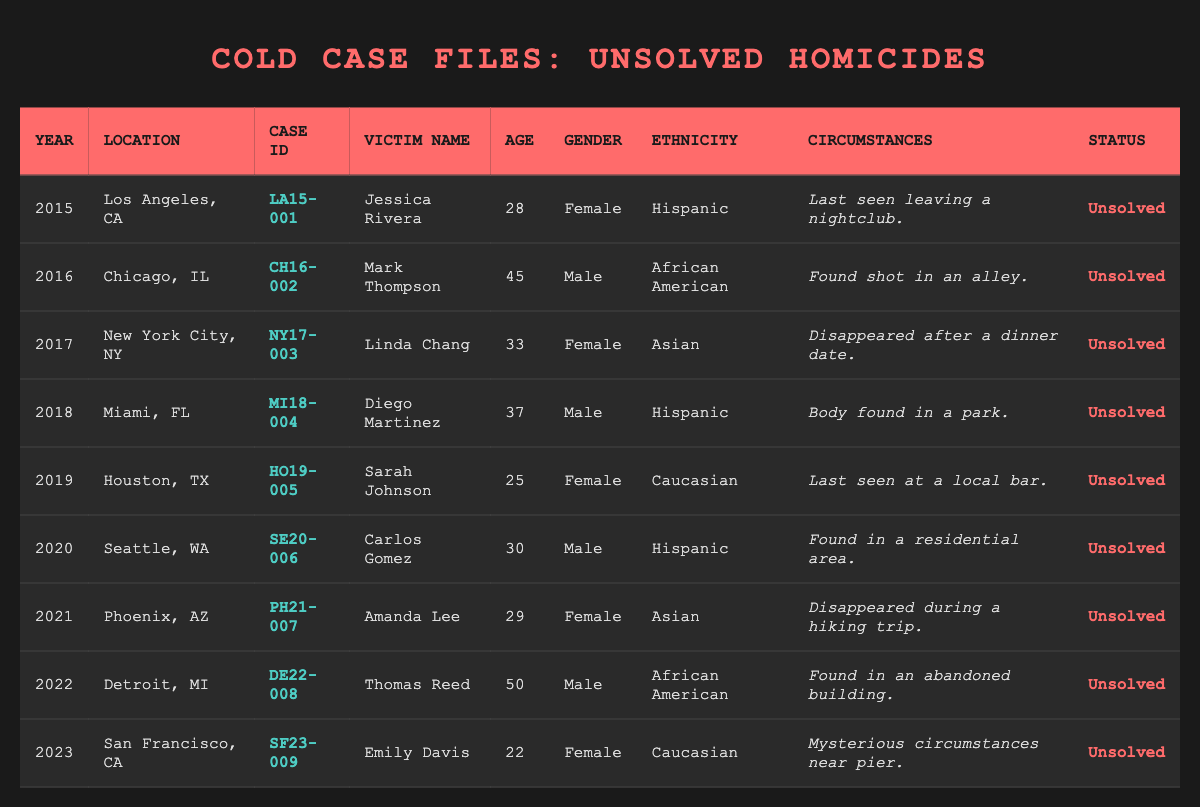What is the age of Jessica Rivera? In the table, under the "Victim Name" column, Jessica Rivera corresponds to the row for the year 2015. The age mentioned in that row is 28.
Answer: 28 How many victims were female in the table? Counting the "Gender" column, there are four females: Jessica Rivera, Linda Chang, Sarah Johnson, and Amanda Lee.
Answer: 4 What was the year when Mark Thompson's case was reported? Mark Thompson's case appears in the row for the year 2016.
Answer: 2016 What are the circumstances surrounding Diego Martinez's death? Looking at the "Circumstances" column for Diego Martinez, the entry states that he was found in a park.
Answer: Found in a park Is the case of Emily Davis solved? From the "Status" column, Emily Davis's case indicates "Unsolved."
Answer: No What is the average age of the victims listed in the table? The ages of the victims are 28, 45, 33, 37, 25, 30, 29, 50, and 22. Summing these gives 28+45+33+37+25+30+29+50+22 = 299. There are 9 victims, so the average age is 299/9 ≈ 33.2.
Answer: 33.2 Which city had the latest reported unsolved homicide case? Reviewing the "Year" column, the latest year listed is 2023, corresponding to the case in San Francisco, CA.
Answer: San Francisco, CA How many male victims are there? Looking at the "Gender" column, the male victims are Mark Thompson, Diego Martinez, Carlos Gomez, and Thomas Reed, totaling four males.
Answer: 4 In what circumstances was Amanda Lee last seen? Referring to Amanda Lee's entry, she disappeared during a hiking trip.
Answer: Disappeared during a hiking trip What is the ethnic background of Sarah Johnson? In the "Ethnicity" column for Sarah Johnson, it states that her ethnicity is Caucasian.
Answer: Caucasian Which victim had the highest age and what was it? In the "Age" column, the highest age listed is 50, which belongs to Thomas Reed.
Answer: 50, Thomas Reed 